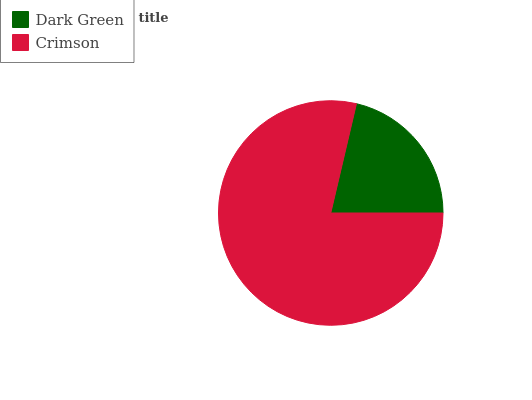Is Dark Green the minimum?
Answer yes or no. Yes. Is Crimson the maximum?
Answer yes or no. Yes. Is Crimson the minimum?
Answer yes or no. No. Is Crimson greater than Dark Green?
Answer yes or no. Yes. Is Dark Green less than Crimson?
Answer yes or no. Yes. Is Dark Green greater than Crimson?
Answer yes or no. No. Is Crimson less than Dark Green?
Answer yes or no. No. Is Crimson the high median?
Answer yes or no. Yes. Is Dark Green the low median?
Answer yes or no. Yes. Is Dark Green the high median?
Answer yes or no. No. Is Crimson the low median?
Answer yes or no. No. 